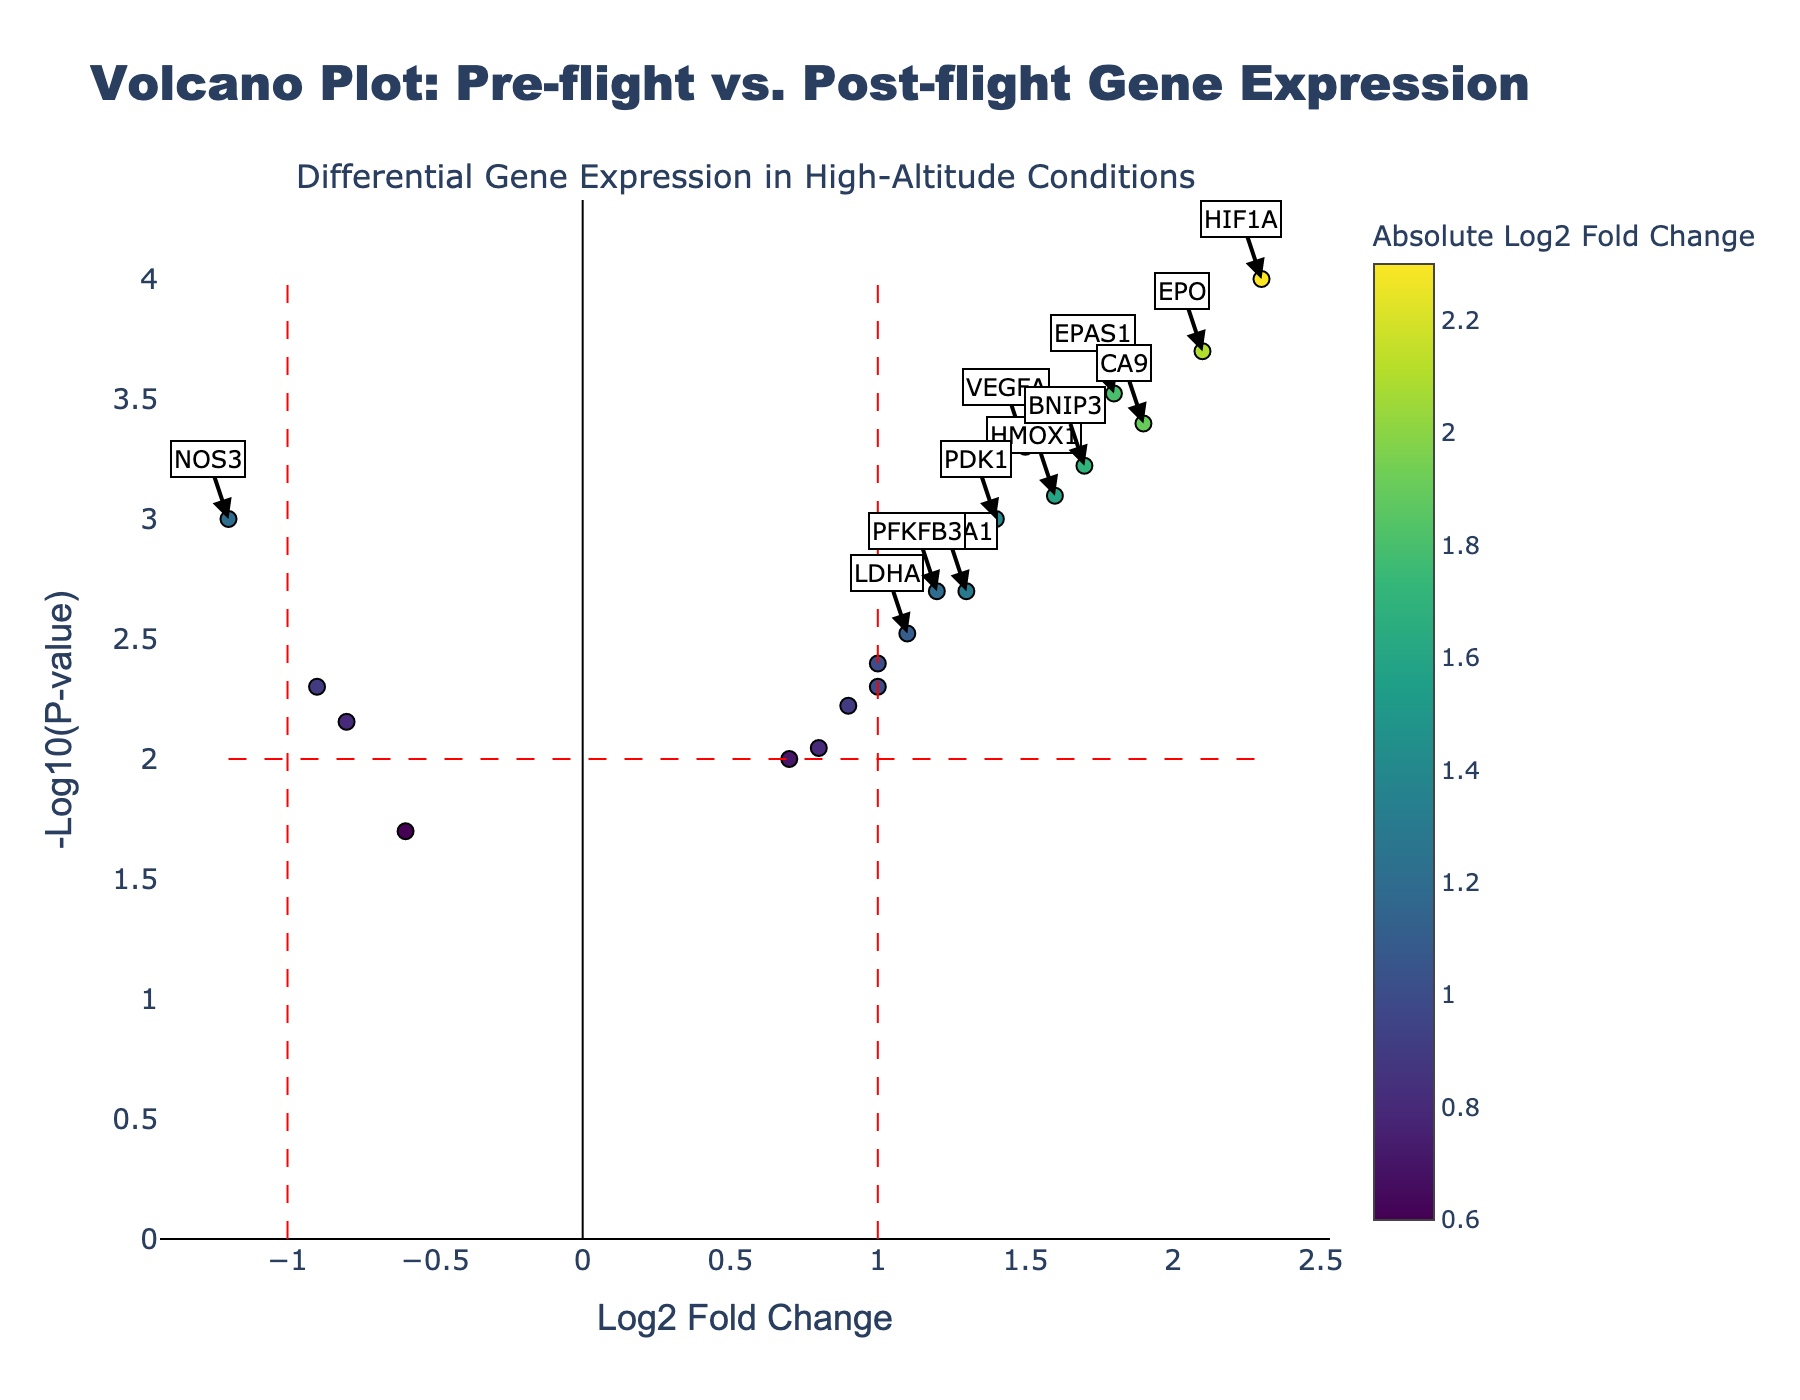What is the title of the plot? The plot's title is located at the top center and reads "Volcano Plot: Pre-flight vs. Post-flight Gene Expression".
Answer: Volcano Plot: Pre-flight vs. Post-flight Gene Expression What do the x-axis and y-axis represent? The x-axis is labeled "Log2 Fold Change", indicating the log base 2 fold changes in gene expression. The y-axis is labeled "-Log10(P-value)", representing the negative log base 10 of the p-value.
Answer: Log2 Fold Change and -Log10(P-value) How many genes are displayed in the plot? Each marker on the plot represents a gene. By counting the entries in the data, we can see that 20 genes are displayed.
Answer: 20 Which gene has the highest log2 fold change and what is its value? The highest log2 fold change can be identified by the furthest right marker on the x-axis. This gene is HIF1A with a log2 fold change of 2.3.
Answer: HIF1A, 2.3 Which genes are considered significant based on the thresholds in the plot, and how is this determined? A gene is significant if its absolute log2 fold change is greater than 1 and its -log10(p-value) is greater than 2. By checking the annotations, the significant genes are HIF1A (2.3, 4), EPAS1 (1.8, 3.52), VEGFA (1.5, 3.3), EPO (2.1, 3.7), and CA9 (1.9, 3.39).
Answer: HIF1A, EPAS1, VEGFA, EPO, CA9 How does the log2 fold change of EPO compare to that of EPAS1? By examining the x-axis values and the hover text, EPO has a log2 fold change of 2.1, while EPAS1 has a log2 fold change of 1.8. EPO's log2 fold change is higher.
Answer: EPO's is higher What can be deduced about the gene CASP3 based on its position in the plot? CASP3 is located on the left side of the plot with a log2 fold change of -0.8, which is below the significance threshold of 1, and its -log10(p-value) of 2.15, which is just over the significance threshold. It is not considered highly significantly regulated.
Answer: Not highly significant Are there any genes with negative log2 fold changes that are also considered significant? To be significant, a gene must have a -log10(p-value) > 2 and an absolute log2 fold change > 1. Checking the annotations, no genes with negative log2 fold changes meet this criteria.
Answer: No What is the shortest -log10(p-value) for any gene in the plot and which gene does it correspond to? The shortest value on the y-axis can be identified by the lowest point. This value is 1.70, corresponding to the gene named CAT.
Answer: CAT, 1.70 